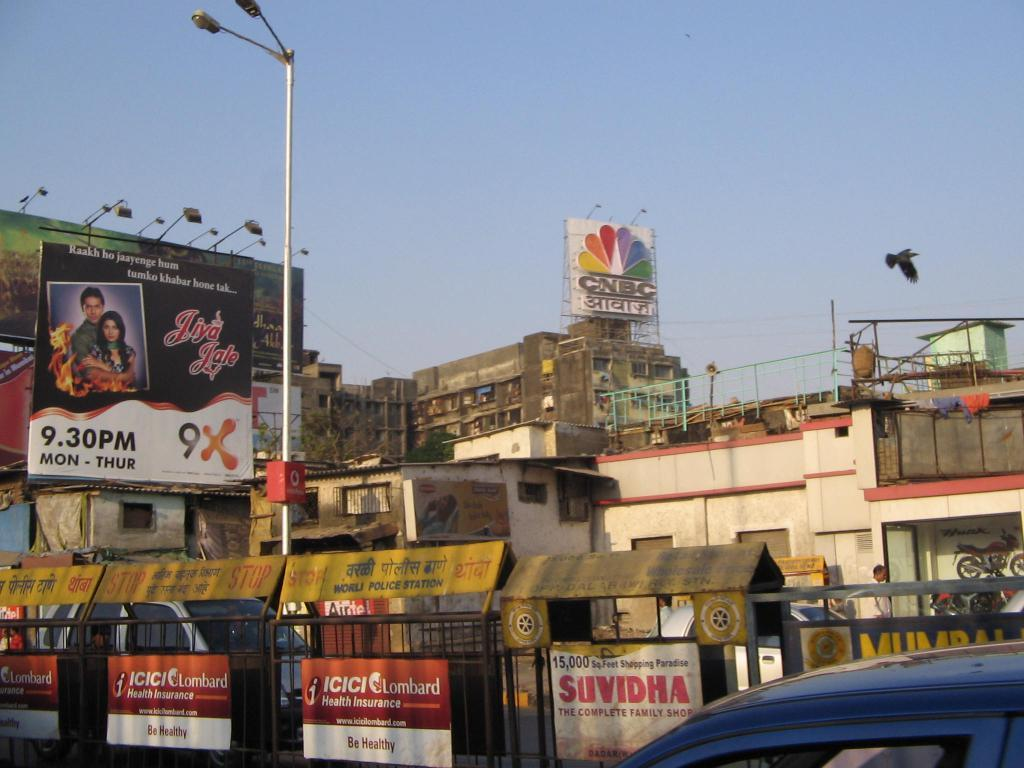Provide a one-sentence caption for the provided image. A CNBC stands atop a building looking down over a very dense indian city. 